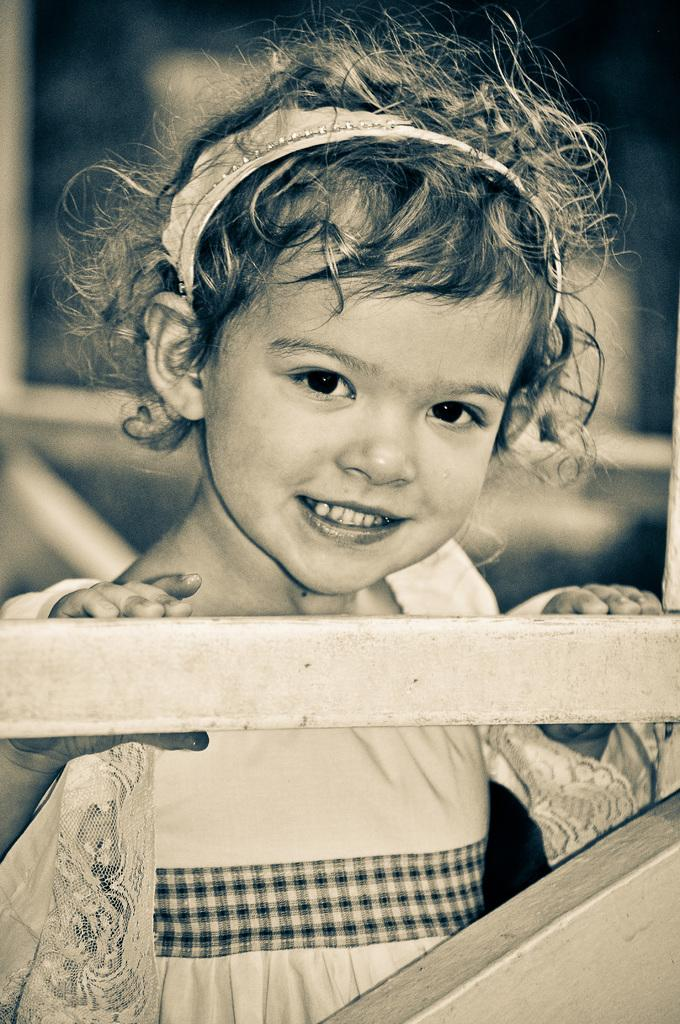What type of image is present in the picture? There is an old photograph in the image. Who or what is featured in the photograph? The photograph contains a child. What is the child holding in the photograph? The child is holding a metal object. How would you describe the background of the photograph? The background of the photograph is blurry. Can you see a kite in the background of the photograph? There is no kite visible in the background of the photograph; it is blurry and does not show any specific objects. How old is the baby in the photograph? The image does not contain a baby; it features a child holding a metal object. 